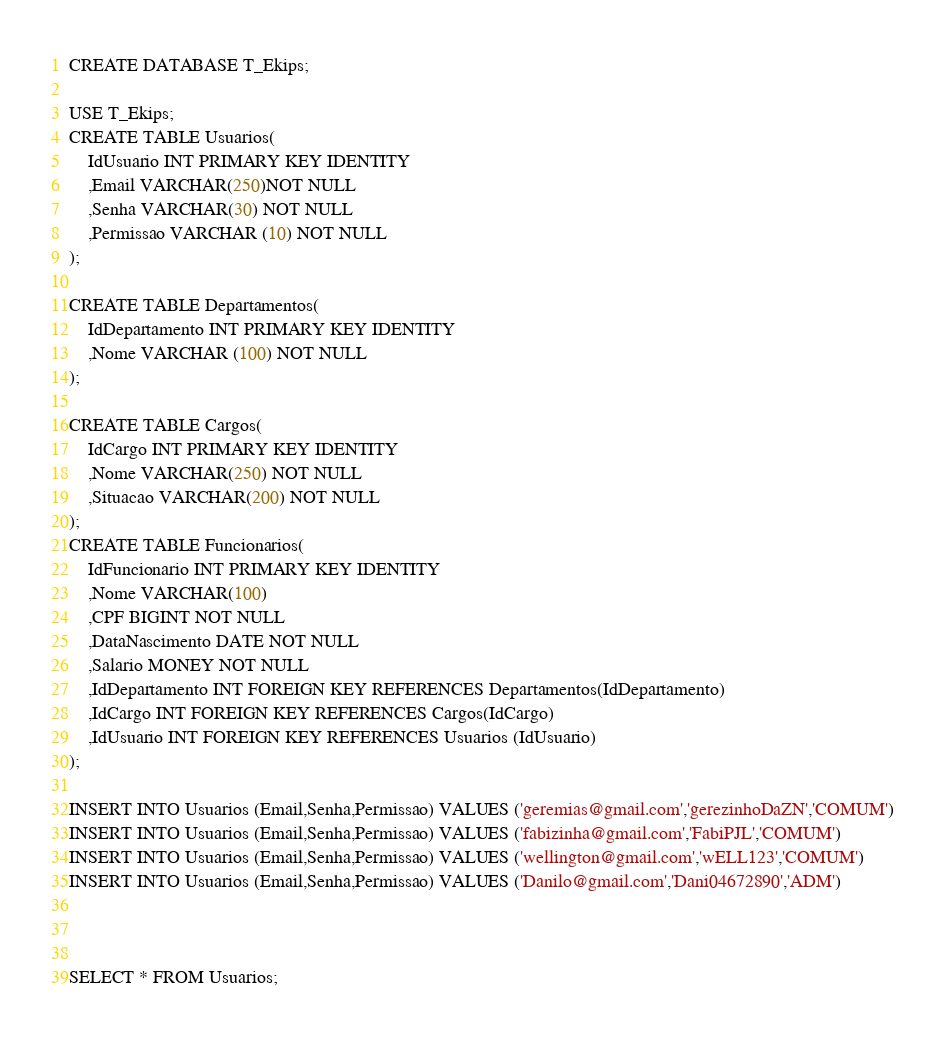Convert code to text. <code><loc_0><loc_0><loc_500><loc_500><_SQL_>CREATE DATABASE T_Ekips;

USE T_Ekips;
CREATE TABLE Usuarios(
	IdUsuario INT PRIMARY KEY IDENTITY
	,Email VARCHAR(250)NOT NULL
	,Senha VARCHAR(30) NOT NULL
	,Permissao VARCHAR (10) NOT NULL
);

CREATE TABLE Departamentos(
	IdDepartamento INT PRIMARY KEY IDENTITY
	,Nome VARCHAR (100) NOT NULL
);

CREATE TABLE Cargos(
	IdCargo INT PRIMARY KEY IDENTITY
	,Nome VARCHAR(250) NOT NULL
	,Situacao VARCHAR(200) NOT NULL
);
CREATE TABLE Funcionarios(
	IdFuncionario INT PRIMARY KEY IDENTITY
	,Nome VARCHAR(100)
	,CPF BIGINT NOT NULL
	,DataNascimento DATE NOT NULL
	,Salario MONEY NOT NULL
	,IdDepartamento INT FOREIGN KEY REFERENCES Departamentos(IdDepartamento)
	,IdCargo INT FOREIGN KEY REFERENCES Cargos(IdCargo)
	,IdUsuario INT FOREIGN KEY REFERENCES Usuarios (IdUsuario)
);

INSERT INTO Usuarios (Email,Senha,Permissao) VALUES ('geremias@gmail.com','gerezinhoDaZN','COMUM')
INSERT INTO Usuarios (Email,Senha,Permissao) VALUES ('fabizinha@gmail.com','FabiPJL','COMUM')
INSERT INTO Usuarios (Email,Senha,Permissao) VALUES ('wellington@gmail.com','wELL123','COMUM')
INSERT INTO Usuarios (Email,Senha,Permissao) VALUES ('Danilo@gmail.com','Dani04672890','ADM')



SELECT * FROM Usuarios;</code> 